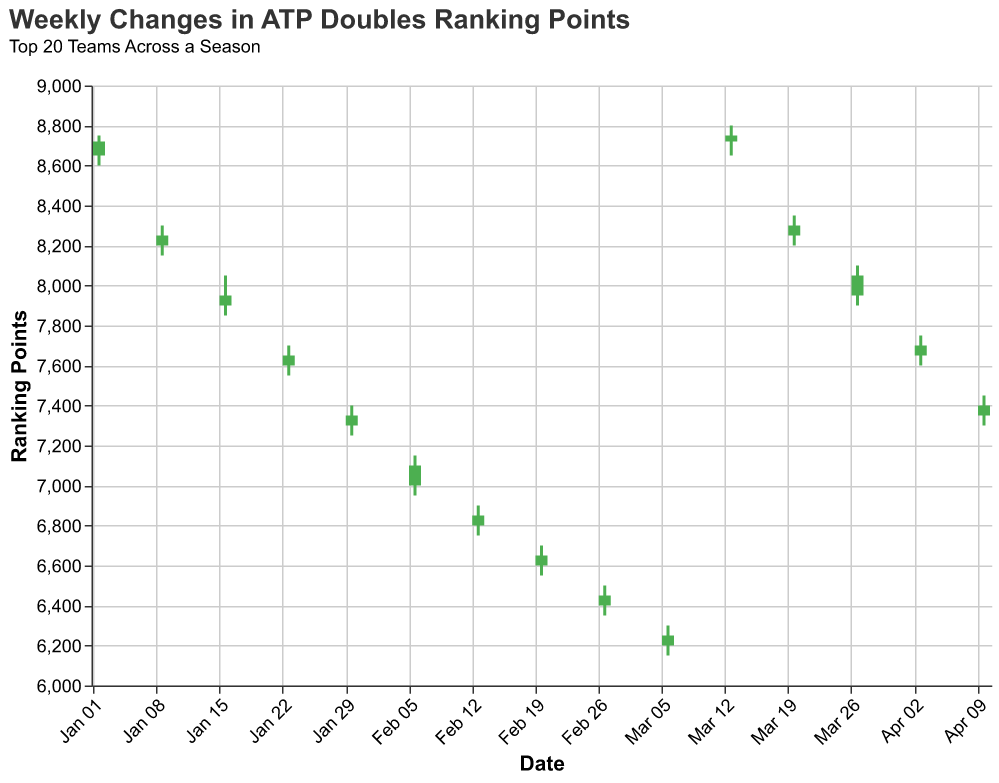What is the title of the chart? The title is usually displayed at the top of the chart. For this figure, the title is provided in the 'title' section.
Answer: Weekly Changes in ATP Doubles Ranking Points Which team had the highest ranking points on March 13, 2023? To determine this, look for the data entry corresponding to March 13, 2023. The team with the highest ranking points (Close value) on that date is Koolhof/Skupski with 8750 points.
Answer: Koolhof/Skupski How did the ranking points for Ram/Salisbury change from January 9, 2023, to March 20, 2023? Compare the Close values for Ram/Salisbury on January 9 and March 20. On January 9, their Close value was 8250, and on March 20, it was 8300. The change is 8300 - 8250 = 50 points.
Answer: Increased by 50 points What was the biggest weekly high rank point achieved, and by which team? Find the highest value in the High column across all teams and dates. The highest rank points achieved are 8800 by the team of Koolhof/Skupski on March 13, 2023.
Answer: 8800 by Koolhof/Skupski Which team experienced the lowest Low ranking points in this data set, and on what date? Look for the smallest value in the Low column. The lowest Low value is 6150, which belongs to Glasspool/Heliovaara on March 6, 2023.
Answer: Glasspool/Heliovaara on March 6, 2023 Were there any weeks when the team's opened and closed with the same ranking points? If so, which team and date? Compare the Open and Close values for each team on each date. There are no instances where the Open and Close values are the same.
Answer: No Which teams had a closing rank increase from January to April? Check the Close values at the end of January and compare them to the Close values in April. Teams with increased closing ranks are Koolhof/Skupski (January 2: 8720, March 13: 8750) and Arevalo/Rojer (January 30: 7350, April 10: 7400).
Answer: Koolhof/Skupski, Arevalo/Rojer What is the average closing rank of Mektic/Pavic in the period covered by the data? Collect the Close values for Mektic/Pavic: 7950 (January 16) and 8050 (March 27). Sum these values and divide by the number of entries: (7950 + 8050) / 2 = 8000.
Answer: 8000 Which team saw the greatest fluctuation in their ranking points (difference between high and low) in a single week? Calculate the difference between the High and Low for each team and week. The greatest fluctuation is 200 points by Mektic/Pavic on January 16, 2023 (High: 8050, Low: 7850).
Answer: Mektic/Pavic 